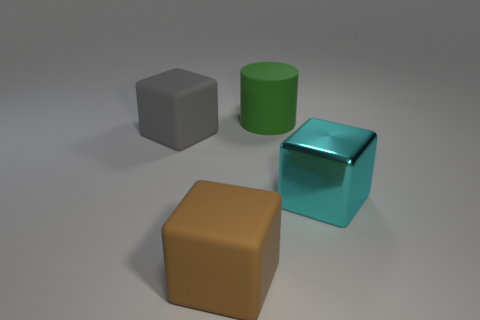Add 1 large cyan things. How many objects exist? 5 Subtract all cylinders. How many objects are left? 3 Add 2 purple metal things. How many purple metal things exist? 2 Subtract 0 gray balls. How many objects are left? 4 Subtract all small red things. Subtract all matte blocks. How many objects are left? 2 Add 1 metallic objects. How many metallic objects are left? 2 